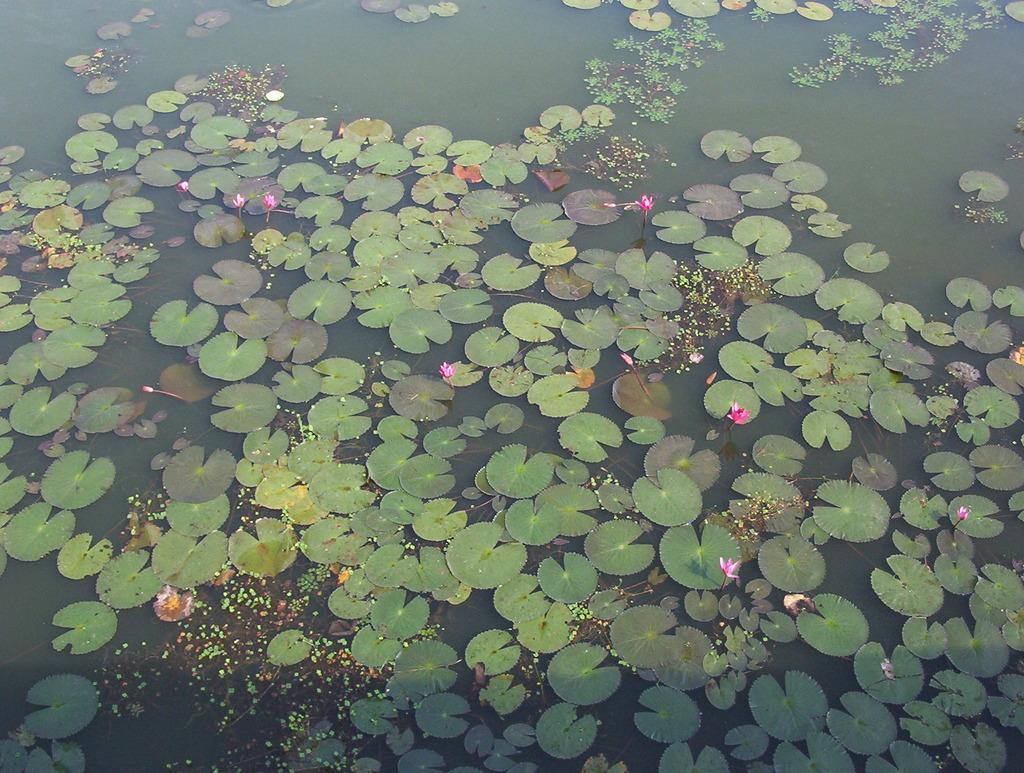Describe this image in one or two sentences. In this image I can see lotus plants and leaves in the water. This image is taken may be during a day. 